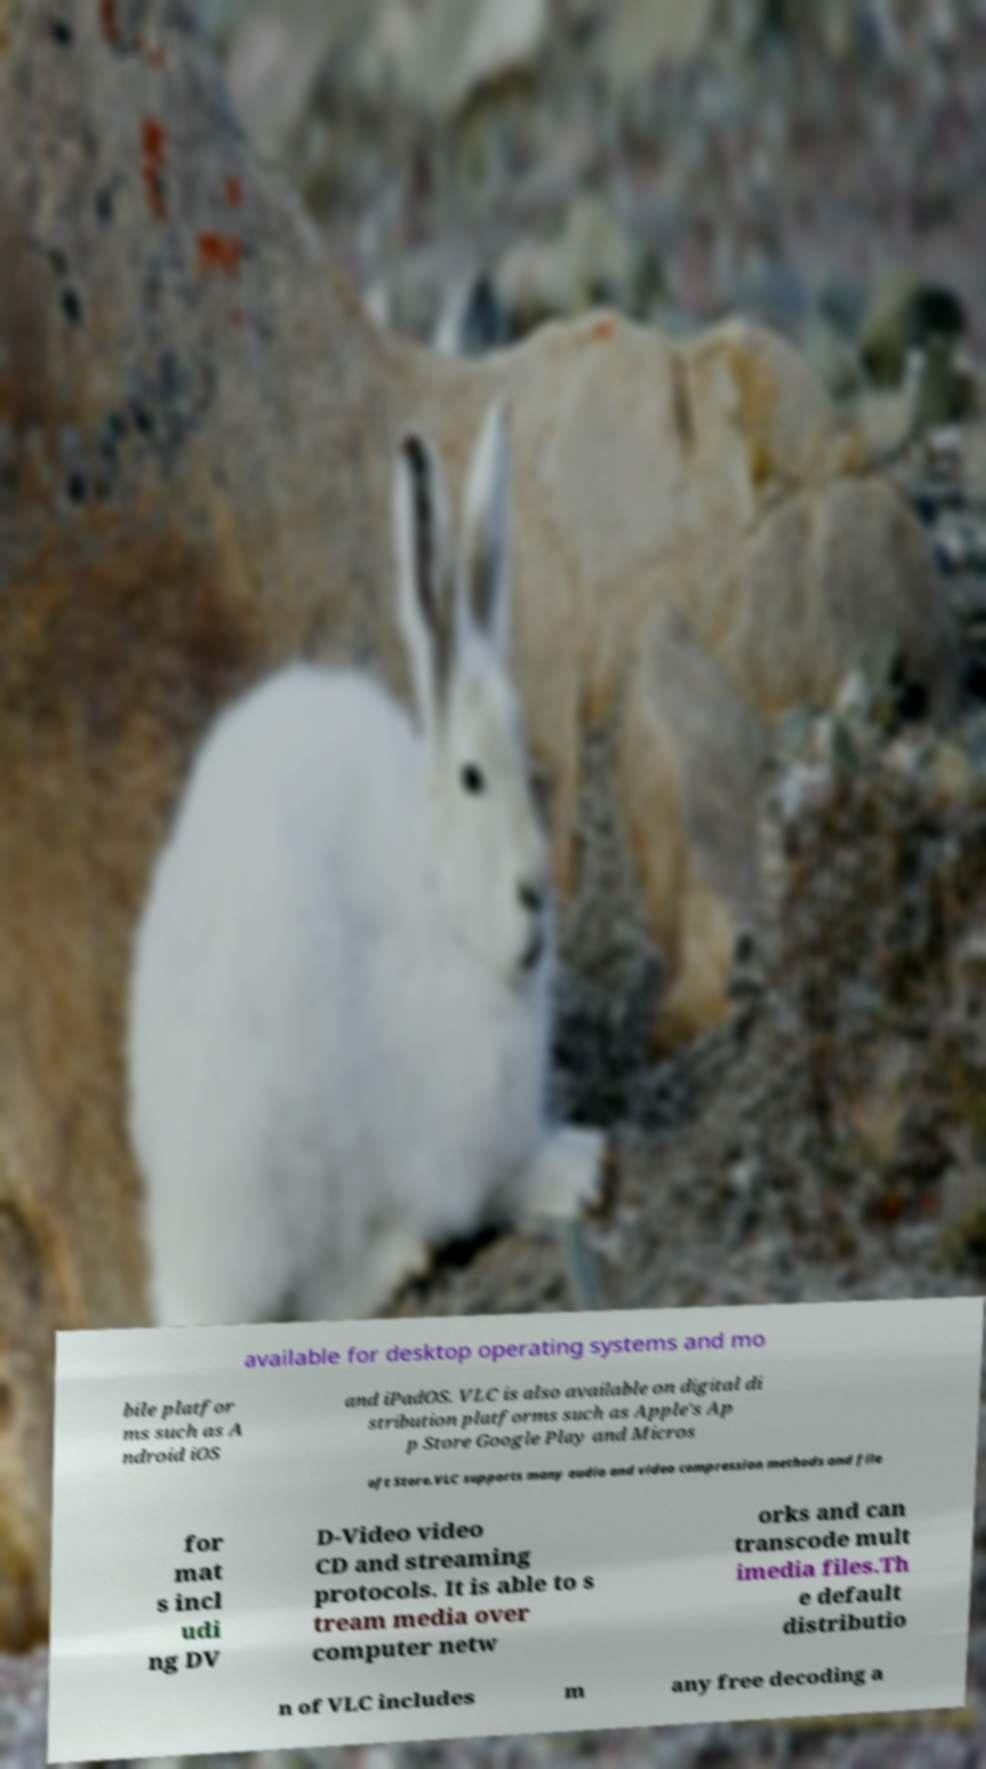What messages or text are displayed in this image? I need them in a readable, typed format. available for desktop operating systems and mo bile platfor ms such as A ndroid iOS and iPadOS. VLC is also available on digital di stribution platforms such as Apple's Ap p Store Google Play and Micros oft Store.VLC supports many audio and video compression methods and file for mat s incl udi ng DV D-Video video CD and streaming protocols. It is able to s tream media over computer netw orks and can transcode mult imedia files.Th e default distributio n of VLC includes m any free decoding a 